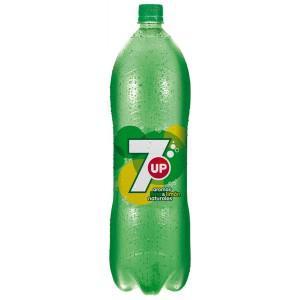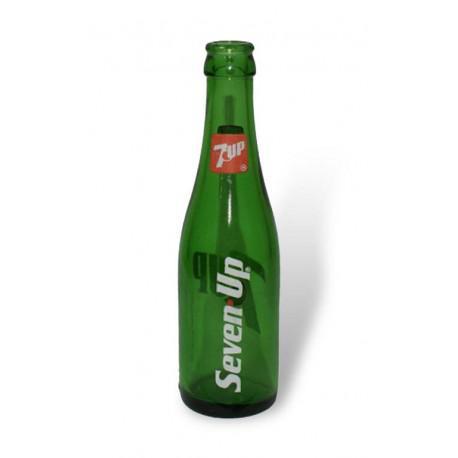The first image is the image on the left, the second image is the image on the right. Analyze the images presented: Is the assertion "There are two bottles, one glass and one plastic." valid? Answer yes or no. Yes. The first image is the image on the left, the second image is the image on the right. Evaluate the accuracy of this statement regarding the images: "The bottle in the image on the left has a white number on the label.". Is it true? Answer yes or no. Yes. 